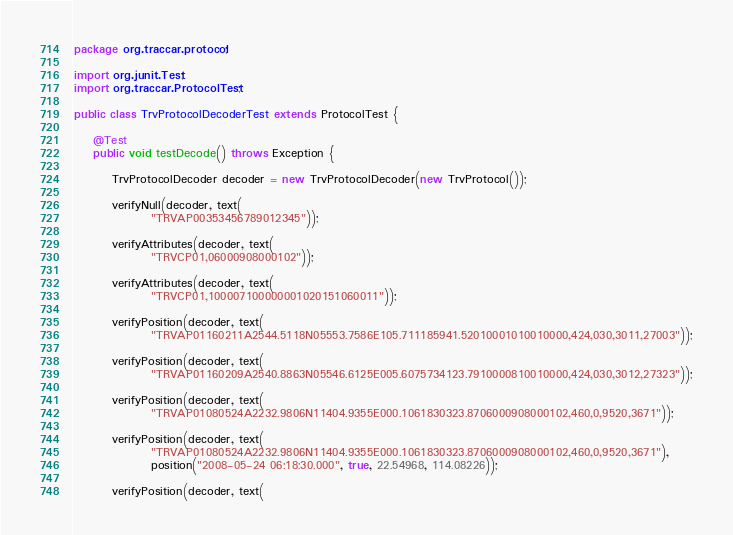Convert code to text. <code><loc_0><loc_0><loc_500><loc_500><_Java_>package org.traccar.protocol;

import org.junit.Test;
import org.traccar.ProtocolTest;

public class TrvProtocolDecoderTest extends ProtocolTest {

    @Test
    public void testDecode() throws Exception {

        TrvProtocolDecoder decoder = new TrvProtocolDecoder(new TrvProtocol());

        verifyNull(decoder, text(
                "TRVAP00353456789012345"));

        verifyAttributes(decoder, text(
                "TRVCP01,06000908000102"));

        verifyAttributes(decoder, text(
                "TRVCP01,100007100000001020151060011"));

        verifyPosition(decoder, text(
                "TRVAP01160211A2544.5118N05553.7586E105.711185941.52010001010010000,424,030,3011,27003"));

        verifyPosition(decoder, text(
                "TRVAP01160209A2540.8863N05546.6125E005.6075734123.7910000810010000,424,030,3012,27323"));

        verifyPosition(decoder, text(
                "TRVAP01080524A2232.9806N11404.9355E000.1061830323.8706000908000102,460,0,9520,3671"));

        verifyPosition(decoder, text(
                "TRVAP01080524A2232.9806N11404.9355E000.1061830323.8706000908000102,460,0,9520,3671"),
                position("2008-05-24 06:18:30.000", true, 22.54968, 114.08226));

        verifyPosition(decoder, text(</code> 